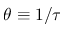Convert formula to latex. <formula><loc_0><loc_0><loc_500><loc_500>\theta \equiv 1 / \tau</formula> 